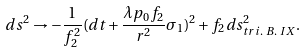Convert formula to latex. <formula><loc_0><loc_0><loc_500><loc_500>d s ^ { 2 } \rightarrow - \frac { 1 } { f _ { 2 } ^ { 2 } } ( d t + \frac { \lambda p _ { 0 } f _ { 2 } } { r ^ { 2 } } \sigma _ { 1 } ) ^ { 2 } + f _ { 2 } d s _ { t r i . \text { } B . \text { } I X } ^ { 2 } .</formula> 